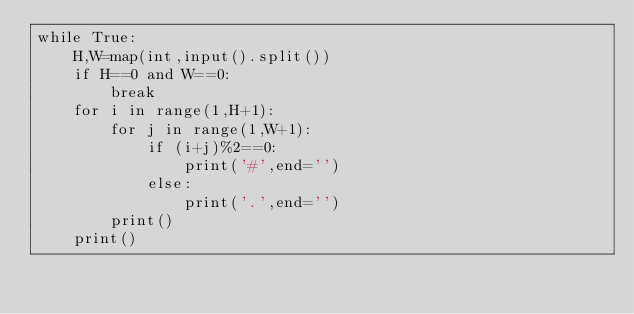Convert code to text. <code><loc_0><loc_0><loc_500><loc_500><_Python_>while True:
    H,W=map(int,input().split())
    if H==0 and W==0:
        break
    for i in range(1,H+1):
        for j in range(1,W+1):
            if (i+j)%2==0:
                print('#',end='')
            else:
                print('.',end='')
        print()
    print()
</code> 